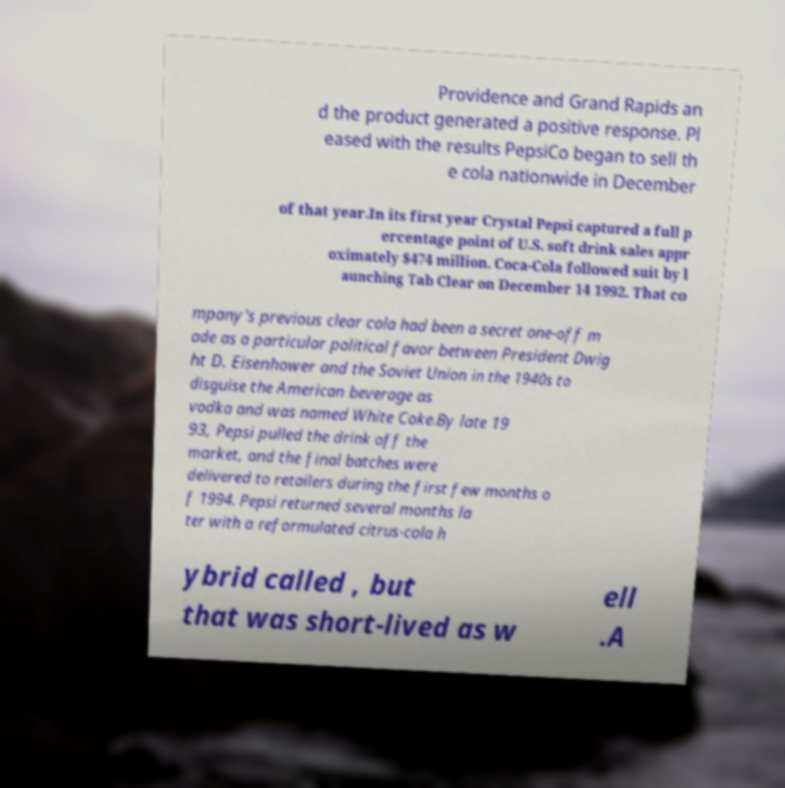Can you read and provide the text displayed in the image?This photo seems to have some interesting text. Can you extract and type it out for me? Providence and Grand Rapids an d the product generated a positive response. Pl eased with the results PepsiCo began to sell th e cola nationwide in December of that year.In its first year Crystal Pepsi captured a full p ercentage point of U.S. soft drink sales appr oximately $474 million. Coca-Cola followed suit by l aunching Tab Clear on December 14 1992. That co mpany's previous clear cola had been a secret one-off m ade as a particular political favor between President Dwig ht D. Eisenhower and the Soviet Union in the 1940s to disguise the American beverage as vodka and was named White Coke.By late 19 93, Pepsi pulled the drink off the market, and the final batches were delivered to retailers during the first few months o f 1994. Pepsi returned several months la ter with a reformulated citrus-cola h ybrid called , but that was short-lived as w ell .A 